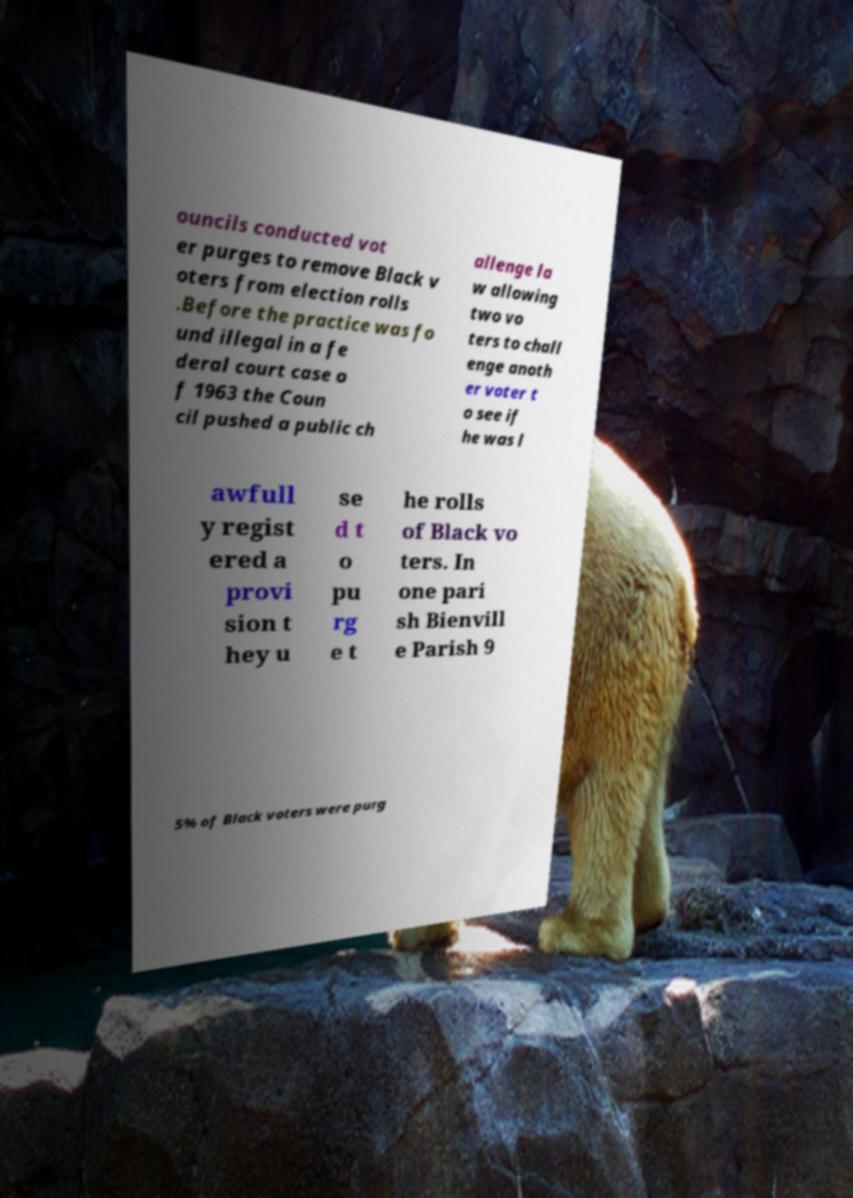Could you extract and type out the text from this image? ouncils conducted vot er purges to remove Black v oters from election rolls .Before the practice was fo und illegal in a fe deral court case o f 1963 the Coun cil pushed a public ch allenge la w allowing two vo ters to chall enge anoth er voter t o see if he was l awfull y regist ered a provi sion t hey u se d t o pu rg e t he rolls of Black vo ters. In one pari sh Bienvill e Parish 9 5% of Black voters were purg 